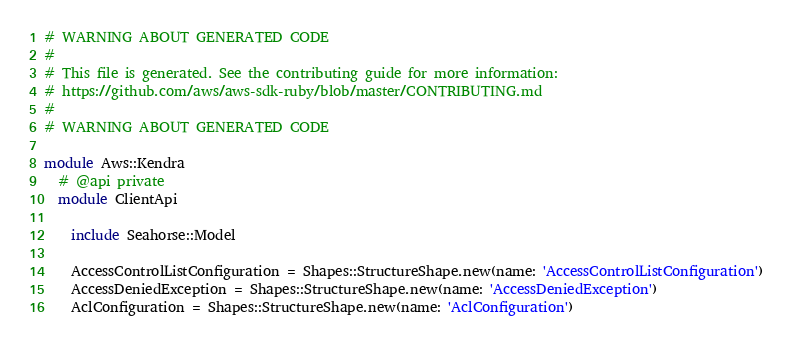<code> <loc_0><loc_0><loc_500><loc_500><_Ruby_># WARNING ABOUT GENERATED CODE
#
# This file is generated. See the contributing guide for more information:
# https://github.com/aws/aws-sdk-ruby/blob/master/CONTRIBUTING.md
#
# WARNING ABOUT GENERATED CODE

module Aws::Kendra
  # @api private
  module ClientApi

    include Seahorse::Model

    AccessControlListConfiguration = Shapes::StructureShape.new(name: 'AccessControlListConfiguration')
    AccessDeniedException = Shapes::StructureShape.new(name: 'AccessDeniedException')
    AclConfiguration = Shapes::StructureShape.new(name: 'AclConfiguration')</code> 